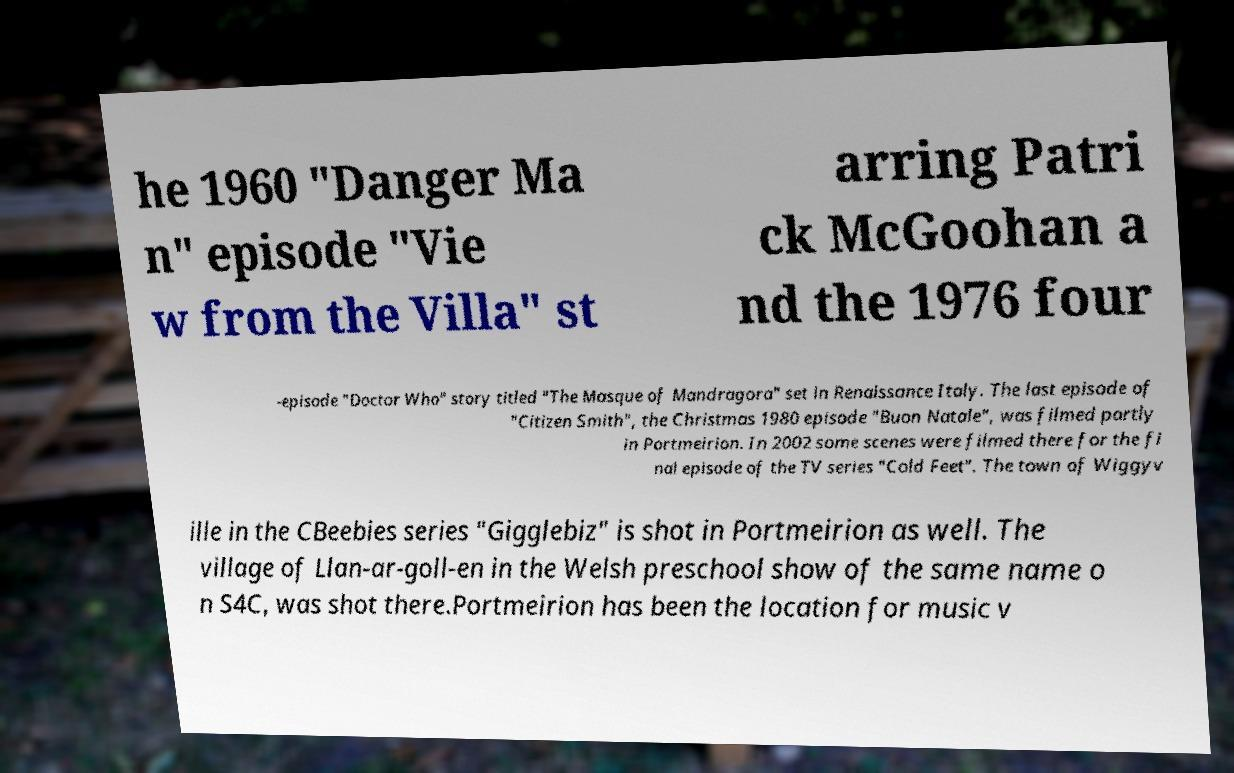There's text embedded in this image that I need extracted. Can you transcribe it verbatim? he 1960 "Danger Ma n" episode "Vie w from the Villa" st arring Patri ck McGoohan a nd the 1976 four -episode "Doctor Who" story titled "The Masque of Mandragora" set in Renaissance Italy. The last episode of "Citizen Smith", the Christmas 1980 episode "Buon Natale", was filmed partly in Portmeirion. In 2002 some scenes were filmed there for the fi nal episode of the TV series "Cold Feet". The town of Wiggyv ille in the CBeebies series "Gigglebiz" is shot in Portmeirion as well. The village of Llan-ar-goll-en in the Welsh preschool show of the same name o n S4C, was shot there.Portmeirion has been the location for music v 